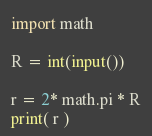Convert code to text. <code><loc_0><loc_0><loc_500><loc_500><_Python_>import math

R = int(input())

r = 2* math.pi * R
print( r )
</code> 